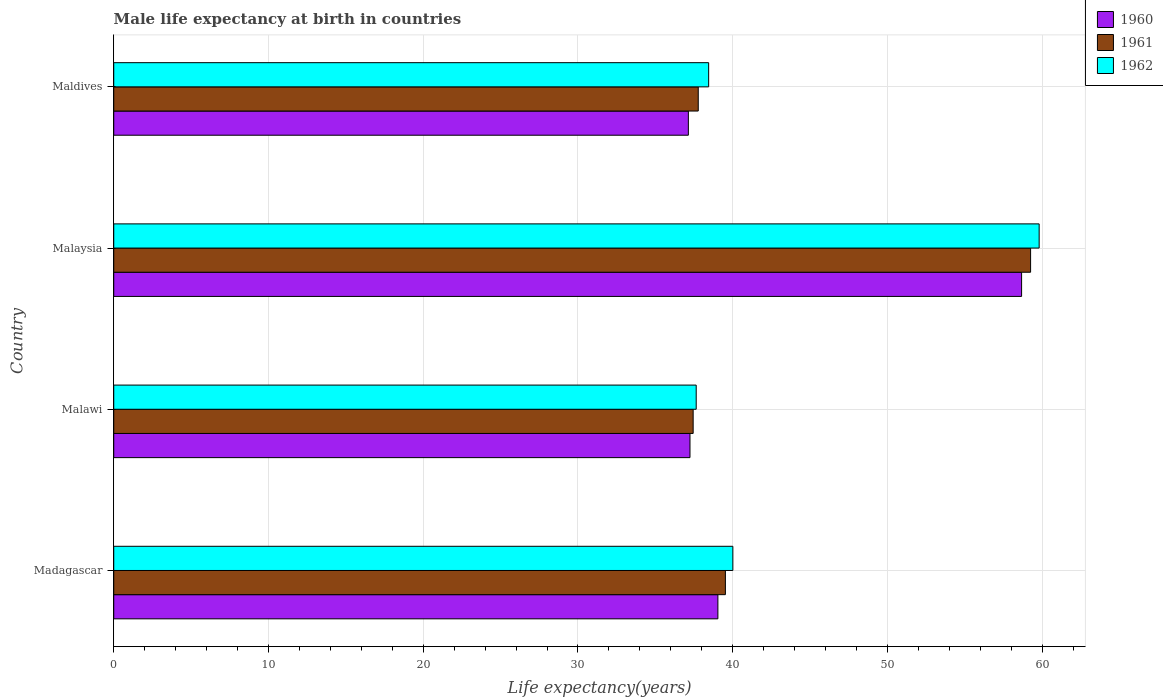How many groups of bars are there?
Offer a terse response. 4. Are the number of bars per tick equal to the number of legend labels?
Offer a terse response. Yes. How many bars are there on the 3rd tick from the top?
Keep it short and to the point. 3. How many bars are there on the 3rd tick from the bottom?
Give a very brief answer. 3. What is the label of the 3rd group of bars from the top?
Provide a succinct answer. Malawi. In how many cases, is the number of bars for a given country not equal to the number of legend labels?
Your answer should be compact. 0. What is the male life expectancy at birth in 1962 in Malaysia?
Give a very brief answer. 59.8. Across all countries, what is the maximum male life expectancy at birth in 1961?
Ensure brevity in your answer.  59.25. Across all countries, what is the minimum male life expectancy at birth in 1962?
Provide a succinct answer. 37.64. In which country was the male life expectancy at birth in 1961 maximum?
Provide a short and direct response. Malaysia. In which country was the male life expectancy at birth in 1961 minimum?
Provide a succinct answer. Malawi. What is the total male life expectancy at birth in 1962 in the graph?
Provide a short and direct response. 175.9. What is the difference between the male life expectancy at birth in 1962 in Madagascar and that in Malaysia?
Your answer should be very brief. -19.79. What is the difference between the male life expectancy at birth in 1961 in Maldives and the male life expectancy at birth in 1962 in Madagascar?
Ensure brevity in your answer.  -2.24. What is the average male life expectancy at birth in 1962 per country?
Offer a very short reply. 43.98. What is the difference between the male life expectancy at birth in 1961 and male life expectancy at birth in 1960 in Madagascar?
Your response must be concise. 0.48. What is the ratio of the male life expectancy at birth in 1961 in Madagascar to that in Malawi?
Keep it short and to the point. 1.06. Is the male life expectancy at birth in 1960 in Madagascar less than that in Malawi?
Keep it short and to the point. No. Is the difference between the male life expectancy at birth in 1961 in Malawi and Malaysia greater than the difference between the male life expectancy at birth in 1960 in Malawi and Malaysia?
Offer a terse response. No. What is the difference between the highest and the second highest male life expectancy at birth in 1960?
Your answer should be compact. 19.63. What is the difference between the highest and the lowest male life expectancy at birth in 1960?
Offer a terse response. 21.53. Is the sum of the male life expectancy at birth in 1960 in Madagascar and Maldives greater than the maximum male life expectancy at birth in 1961 across all countries?
Give a very brief answer. Yes. What does the 2nd bar from the top in Maldives represents?
Provide a short and direct response. 1961. What does the 3rd bar from the bottom in Madagascar represents?
Your response must be concise. 1962. Is it the case that in every country, the sum of the male life expectancy at birth in 1960 and male life expectancy at birth in 1962 is greater than the male life expectancy at birth in 1961?
Keep it short and to the point. Yes. How many bars are there?
Keep it short and to the point. 12. What is the difference between two consecutive major ticks on the X-axis?
Offer a terse response. 10. Are the values on the major ticks of X-axis written in scientific E-notation?
Provide a short and direct response. No. Does the graph contain any zero values?
Your answer should be very brief. No. Where does the legend appear in the graph?
Offer a very short reply. Top right. What is the title of the graph?
Offer a terse response. Male life expectancy at birth in countries. What is the label or title of the X-axis?
Provide a succinct answer. Life expectancy(years). What is the label or title of the Y-axis?
Ensure brevity in your answer.  Country. What is the Life expectancy(years) in 1960 in Madagascar?
Give a very brief answer. 39.04. What is the Life expectancy(years) in 1961 in Madagascar?
Your answer should be very brief. 39.53. What is the Life expectancy(years) of 1962 in Madagascar?
Make the answer very short. 40.01. What is the Life expectancy(years) of 1960 in Malawi?
Offer a terse response. 37.24. What is the Life expectancy(years) in 1961 in Malawi?
Your answer should be very brief. 37.44. What is the Life expectancy(years) of 1962 in Malawi?
Offer a terse response. 37.64. What is the Life expectancy(years) in 1960 in Malaysia?
Offer a very short reply. 58.67. What is the Life expectancy(years) of 1961 in Malaysia?
Provide a short and direct response. 59.25. What is the Life expectancy(years) of 1962 in Malaysia?
Give a very brief answer. 59.8. What is the Life expectancy(years) in 1960 in Maldives?
Give a very brief answer. 37.13. What is the Life expectancy(years) in 1961 in Maldives?
Provide a short and direct response. 37.77. What is the Life expectancy(years) in 1962 in Maldives?
Provide a succinct answer. 38.45. Across all countries, what is the maximum Life expectancy(years) in 1960?
Make the answer very short. 58.67. Across all countries, what is the maximum Life expectancy(years) of 1961?
Your answer should be compact. 59.25. Across all countries, what is the maximum Life expectancy(years) of 1962?
Your answer should be very brief. 59.8. Across all countries, what is the minimum Life expectancy(years) of 1960?
Provide a short and direct response. 37.13. Across all countries, what is the minimum Life expectancy(years) of 1961?
Give a very brief answer. 37.44. Across all countries, what is the minimum Life expectancy(years) in 1962?
Ensure brevity in your answer.  37.64. What is the total Life expectancy(years) in 1960 in the graph?
Your answer should be compact. 172.08. What is the total Life expectancy(years) in 1961 in the graph?
Your response must be concise. 173.99. What is the total Life expectancy(years) of 1962 in the graph?
Give a very brief answer. 175.9. What is the difference between the Life expectancy(years) of 1960 in Madagascar and that in Malawi?
Offer a terse response. 1.8. What is the difference between the Life expectancy(years) in 1961 in Madagascar and that in Malawi?
Your response must be concise. 2.08. What is the difference between the Life expectancy(years) of 1962 in Madagascar and that in Malawi?
Provide a succinct answer. 2.37. What is the difference between the Life expectancy(years) in 1960 in Madagascar and that in Malaysia?
Provide a short and direct response. -19.63. What is the difference between the Life expectancy(years) of 1961 in Madagascar and that in Malaysia?
Provide a short and direct response. -19.72. What is the difference between the Life expectancy(years) in 1962 in Madagascar and that in Malaysia?
Your answer should be very brief. -19.79. What is the difference between the Life expectancy(years) of 1960 in Madagascar and that in Maldives?
Provide a short and direct response. 1.91. What is the difference between the Life expectancy(years) of 1961 in Madagascar and that in Maldives?
Provide a short and direct response. 1.75. What is the difference between the Life expectancy(years) in 1962 in Madagascar and that in Maldives?
Your response must be concise. 1.56. What is the difference between the Life expectancy(years) of 1960 in Malawi and that in Malaysia?
Provide a succinct answer. -21.43. What is the difference between the Life expectancy(years) of 1961 in Malawi and that in Malaysia?
Offer a terse response. -21.81. What is the difference between the Life expectancy(years) of 1962 in Malawi and that in Malaysia?
Your answer should be compact. -22.16. What is the difference between the Life expectancy(years) in 1960 in Malawi and that in Maldives?
Make the answer very short. 0.1. What is the difference between the Life expectancy(years) of 1961 in Malawi and that in Maldives?
Give a very brief answer. -0.33. What is the difference between the Life expectancy(years) of 1962 in Malawi and that in Maldives?
Make the answer very short. -0.81. What is the difference between the Life expectancy(years) in 1960 in Malaysia and that in Maldives?
Provide a succinct answer. 21.54. What is the difference between the Life expectancy(years) of 1961 in Malaysia and that in Maldives?
Your response must be concise. 21.48. What is the difference between the Life expectancy(years) of 1962 in Malaysia and that in Maldives?
Your answer should be very brief. 21.36. What is the difference between the Life expectancy(years) in 1960 in Madagascar and the Life expectancy(years) in 1961 in Malawi?
Provide a succinct answer. 1.6. What is the difference between the Life expectancy(years) in 1960 in Madagascar and the Life expectancy(years) in 1962 in Malawi?
Your response must be concise. 1.4. What is the difference between the Life expectancy(years) of 1961 in Madagascar and the Life expectancy(years) of 1962 in Malawi?
Keep it short and to the point. 1.89. What is the difference between the Life expectancy(years) in 1960 in Madagascar and the Life expectancy(years) in 1961 in Malaysia?
Offer a terse response. -20.21. What is the difference between the Life expectancy(years) in 1960 in Madagascar and the Life expectancy(years) in 1962 in Malaysia?
Provide a succinct answer. -20.76. What is the difference between the Life expectancy(years) in 1961 in Madagascar and the Life expectancy(years) in 1962 in Malaysia?
Provide a succinct answer. -20.28. What is the difference between the Life expectancy(years) of 1960 in Madagascar and the Life expectancy(years) of 1961 in Maldives?
Make the answer very short. 1.27. What is the difference between the Life expectancy(years) of 1960 in Madagascar and the Life expectancy(years) of 1962 in Maldives?
Your answer should be compact. 0.6. What is the difference between the Life expectancy(years) in 1961 in Madagascar and the Life expectancy(years) in 1962 in Maldives?
Make the answer very short. 1.08. What is the difference between the Life expectancy(years) in 1960 in Malawi and the Life expectancy(years) in 1961 in Malaysia?
Ensure brevity in your answer.  -22.01. What is the difference between the Life expectancy(years) of 1960 in Malawi and the Life expectancy(years) of 1962 in Malaysia?
Ensure brevity in your answer.  -22.57. What is the difference between the Life expectancy(years) in 1961 in Malawi and the Life expectancy(years) in 1962 in Malaysia?
Ensure brevity in your answer.  -22.36. What is the difference between the Life expectancy(years) of 1960 in Malawi and the Life expectancy(years) of 1961 in Maldives?
Keep it short and to the point. -0.53. What is the difference between the Life expectancy(years) of 1960 in Malawi and the Life expectancy(years) of 1962 in Maldives?
Give a very brief answer. -1.21. What is the difference between the Life expectancy(years) of 1961 in Malawi and the Life expectancy(years) of 1962 in Maldives?
Ensure brevity in your answer.  -1. What is the difference between the Life expectancy(years) of 1960 in Malaysia and the Life expectancy(years) of 1961 in Maldives?
Give a very brief answer. 20.9. What is the difference between the Life expectancy(years) of 1960 in Malaysia and the Life expectancy(years) of 1962 in Maldives?
Give a very brief answer. 20.22. What is the difference between the Life expectancy(years) of 1961 in Malaysia and the Life expectancy(years) of 1962 in Maldives?
Provide a short and direct response. 20.8. What is the average Life expectancy(years) in 1960 per country?
Your response must be concise. 43.02. What is the average Life expectancy(years) of 1961 per country?
Offer a very short reply. 43.5. What is the average Life expectancy(years) of 1962 per country?
Keep it short and to the point. 43.98. What is the difference between the Life expectancy(years) of 1960 and Life expectancy(years) of 1961 in Madagascar?
Offer a terse response. -0.48. What is the difference between the Life expectancy(years) in 1960 and Life expectancy(years) in 1962 in Madagascar?
Offer a terse response. -0.97. What is the difference between the Life expectancy(years) of 1961 and Life expectancy(years) of 1962 in Madagascar?
Offer a terse response. -0.48. What is the difference between the Life expectancy(years) in 1960 and Life expectancy(years) in 1961 in Malawi?
Offer a very short reply. -0.2. What is the difference between the Life expectancy(years) of 1960 and Life expectancy(years) of 1962 in Malawi?
Keep it short and to the point. -0.4. What is the difference between the Life expectancy(years) in 1961 and Life expectancy(years) in 1962 in Malawi?
Make the answer very short. -0.2. What is the difference between the Life expectancy(years) in 1960 and Life expectancy(years) in 1961 in Malaysia?
Ensure brevity in your answer.  -0.58. What is the difference between the Life expectancy(years) in 1960 and Life expectancy(years) in 1962 in Malaysia?
Your answer should be very brief. -1.14. What is the difference between the Life expectancy(years) in 1961 and Life expectancy(years) in 1962 in Malaysia?
Give a very brief answer. -0.55. What is the difference between the Life expectancy(years) in 1960 and Life expectancy(years) in 1961 in Maldives?
Your answer should be very brief. -0.64. What is the difference between the Life expectancy(years) of 1960 and Life expectancy(years) of 1962 in Maldives?
Offer a terse response. -1.31. What is the difference between the Life expectancy(years) in 1961 and Life expectancy(years) in 1962 in Maldives?
Make the answer very short. -0.67. What is the ratio of the Life expectancy(years) in 1960 in Madagascar to that in Malawi?
Your answer should be very brief. 1.05. What is the ratio of the Life expectancy(years) in 1961 in Madagascar to that in Malawi?
Make the answer very short. 1.06. What is the ratio of the Life expectancy(years) in 1962 in Madagascar to that in Malawi?
Give a very brief answer. 1.06. What is the ratio of the Life expectancy(years) of 1960 in Madagascar to that in Malaysia?
Offer a very short reply. 0.67. What is the ratio of the Life expectancy(years) in 1961 in Madagascar to that in Malaysia?
Your answer should be compact. 0.67. What is the ratio of the Life expectancy(years) of 1962 in Madagascar to that in Malaysia?
Provide a short and direct response. 0.67. What is the ratio of the Life expectancy(years) of 1960 in Madagascar to that in Maldives?
Provide a succinct answer. 1.05. What is the ratio of the Life expectancy(years) of 1961 in Madagascar to that in Maldives?
Offer a very short reply. 1.05. What is the ratio of the Life expectancy(years) in 1962 in Madagascar to that in Maldives?
Ensure brevity in your answer.  1.04. What is the ratio of the Life expectancy(years) in 1960 in Malawi to that in Malaysia?
Ensure brevity in your answer.  0.63. What is the ratio of the Life expectancy(years) of 1961 in Malawi to that in Malaysia?
Your answer should be very brief. 0.63. What is the ratio of the Life expectancy(years) in 1962 in Malawi to that in Malaysia?
Your answer should be very brief. 0.63. What is the ratio of the Life expectancy(years) of 1960 in Malawi to that in Maldives?
Offer a very short reply. 1. What is the ratio of the Life expectancy(years) of 1962 in Malawi to that in Maldives?
Keep it short and to the point. 0.98. What is the ratio of the Life expectancy(years) of 1960 in Malaysia to that in Maldives?
Make the answer very short. 1.58. What is the ratio of the Life expectancy(years) of 1961 in Malaysia to that in Maldives?
Your answer should be compact. 1.57. What is the ratio of the Life expectancy(years) in 1962 in Malaysia to that in Maldives?
Ensure brevity in your answer.  1.56. What is the difference between the highest and the second highest Life expectancy(years) in 1960?
Provide a succinct answer. 19.63. What is the difference between the highest and the second highest Life expectancy(years) in 1961?
Your answer should be compact. 19.72. What is the difference between the highest and the second highest Life expectancy(years) of 1962?
Your answer should be compact. 19.79. What is the difference between the highest and the lowest Life expectancy(years) of 1960?
Make the answer very short. 21.54. What is the difference between the highest and the lowest Life expectancy(years) of 1961?
Keep it short and to the point. 21.81. What is the difference between the highest and the lowest Life expectancy(years) in 1962?
Offer a terse response. 22.16. 